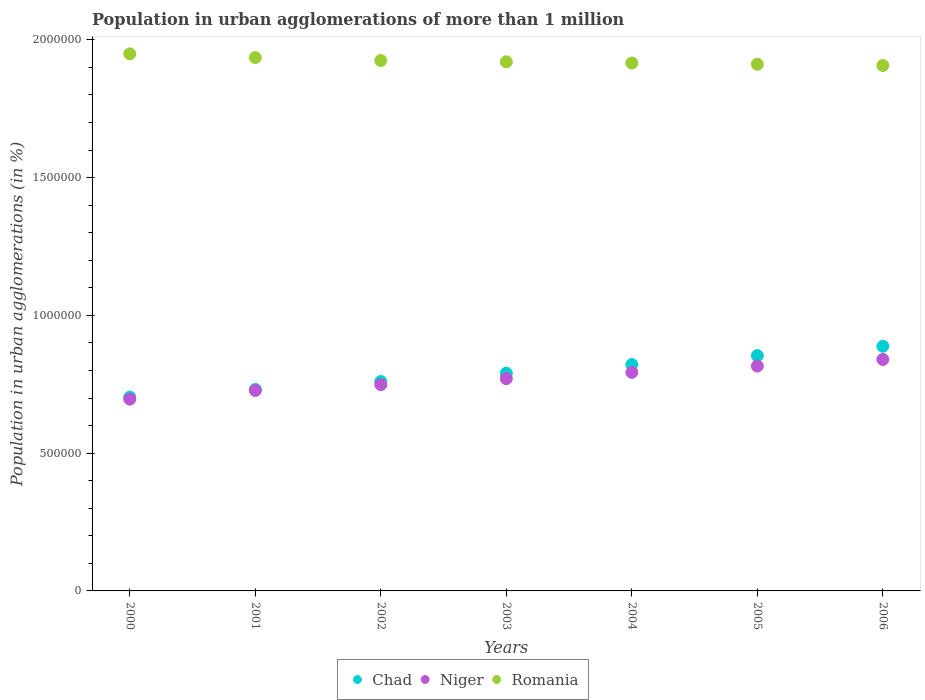How many different coloured dotlines are there?
Provide a succinct answer. 3. What is the population in urban agglomerations in Romania in 2000?
Provide a succinct answer. 1.95e+06. Across all years, what is the maximum population in urban agglomerations in Romania?
Your answer should be compact. 1.95e+06. Across all years, what is the minimum population in urban agglomerations in Chad?
Ensure brevity in your answer.  7.03e+05. In which year was the population in urban agglomerations in Niger maximum?
Offer a very short reply. 2006. What is the total population in urban agglomerations in Romania in the graph?
Provide a succinct answer. 1.35e+07. What is the difference between the population in urban agglomerations in Romania in 2001 and that in 2004?
Your answer should be compact. 1.99e+04. What is the difference between the population in urban agglomerations in Niger in 2006 and the population in urban agglomerations in Chad in 2000?
Keep it short and to the point. 1.37e+05. What is the average population in urban agglomerations in Romania per year?
Ensure brevity in your answer.  1.92e+06. In the year 2001, what is the difference between the population in urban agglomerations in Romania and population in urban agglomerations in Chad?
Your response must be concise. 1.20e+06. What is the ratio of the population in urban agglomerations in Chad in 2000 to that in 2002?
Make the answer very short. 0.93. What is the difference between the highest and the second highest population in urban agglomerations in Niger?
Your response must be concise. 2.38e+04. What is the difference between the highest and the lowest population in urban agglomerations in Niger?
Your answer should be compact. 1.44e+05. In how many years, is the population in urban agglomerations in Niger greater than the average population in urban agglomerations in Niger taken over all years?
Provide a succinct answer. 4. Is the sum of the population in urban agglomerations in Chad in 2000 and 2002 greater than the maximum population in urban agglomerations in Niger across all years?
Your answer should be very brief. Yes. Does the population in urban agglomerations in Niger monotonically increase over the years?
Your answer should be very brief. Yes. Is the population in urban agglomerations in Chad strictly greater than the population in urban agglomerations in Niger over the years?
Your answer should be very brief. Yes. How many dotlines are there?
Your answer should be very brief. 3. Are the values on the major ticks of Y-axis written in scientific E-notation?
Make the answer very short. No. Does the graph contain any zero values?
Your answer should be compact. No. How many legend labels are there?
Ensure brevity in your answer.  3. How are the legend labels stacked?
Keep it short and to the point. Horizontal. What is the title of the graph?
Provide a succinct answer. Population in urban agglomerations of more than 1 million. What is the label or title of the X-axis?
Give a very brief answer. Years. What is the label or title of the Y-axis?
Ensure brevity in your answer.  Population in urban agglomerations (in %). What is the Population in urban agglomerations (in %) in Chad in 2000?
Your response must be concise. 7.03e+05. What is the Population in urban agglomerations (in %) in Niger in 2000?
Give a very brief answer. 6.96e+05. What is the Population in urban agglomerations (in %) in Romania in 2000?
Your answer should be compact. 1.95e+06. What is the Population in urban agglomerations (in %) of Chad in 2001?
Your answer should be compact. 7.31e+05. What is the Population in urban agglomerations (in %) of Niger in 2001?
Provide a short and direct response. 7.27e+05. What is the Population in urban agglomerations (in %) of Romania in 2001?
Provide a succinct answer. 1.94e+06. What is the Population in urban agglomerations (in %) in Chad in 2002?
Provide a succinct answer. 7.60e+05. What is the Population in urban agglomerations (in %) in Niger in 2002?
Provide a short and direct response. 7.49e+05. What is the Population in urban agglomerations (in %) of Romania in 2002?
Your answer should be very brief. 1.93e+06. What is the Population in urban agglomerations (in %) of Chad in 2003?
Offer a terse response. 7.90e+05. What is the Population in urban agglomerations (in %) of Niger in 2003?
Provide a short and direct response. 7.71e+05. What is the Population in urban agglomerations (in %) in Romania in 2003?
Keep it short and to the point. 1.92e+06. What is the Population in urban agglomerations (in %) of Chad in 2004?
Provide a succinct answer. 8.22e+05. What is the Population in urban agglomerations (in %) in Niger in 2004?
Your response must be concise. 7.93e+05. What is the Population in urban agglomerations (in %) in Romania in 2004?
Provide a short and direct response. 1.92e+06. What is the Population in urban agglomerations (in %) of Chad in 2005?
Your answer should be very brief. 8.54e+05. What is the Population in urban agglomerations (in %) in Niger in 2005?
Your response must be concise. 8.16e+05. What is the Population in urban agglomerations (in %) in Romania in 2005?
Offer a very short reply. 1.91e+06. What is the Population in urban agglomerations (in %) of Chad in 2006?
Provide a short and direct response. 8.88e+05. What is the Population in urban agglomerations (in %) in Niger in 2006?
Provide a short and direct response. 8.40e+05. What is the Population in urban agglomerations (in %) in Romania in 2006?
Ensure brevity in your answer.  1.91e+06. Across all years, what is the maximum Population in urban agglomerations (in %) in Chad?
Give a very brief answer. 8.88e+05. Across all years, what is the maximum Population in urban agglomerations (in %) of Niger?
Your answer should be compact. 8.40e+05. Across all years, what is the maximum Population in urban agglomerations (in %) of Romania?
Ensure brevity in your answer.  1.95e+06. Across all years, what is the minimum Population in urban agglomerations (in %) of Chad?
Offer a terse response. 7.03e+05. Across all years, what is the minimum Population in urban agglomerations (in %) in Niger?
Provide a short and direct response. 6.96e+05. Across all years, what is the minimum Population in urban agglomerations (in %) in Romania?
Offer a terse response. 1.91e+06. What is the total Population in urban agglomerations (in %) in Chad in the graph?
Your answer should be compact. 5.55e+06. What is the total Population in urban agglomerations (in %) of Niger in the graph?
Give a very brief answer. 5.39e+06. What is the total Population in urban agglomerations (in %) in Romania in the graph?
Your answer should be compact. 1.35e+07. What is the difference between the Population in urban agglomerations (in %) of Chad in 2000 and that in 2001?
Provide a short and direct response. -2.78e+04. What is the difference between the Population in urban agglomerations (in %) of Niger in 2000 and that in 2001?
Provide a succinct answer. -3.14e+04. What is the difference between the Population in urban agglomerations (in %) in Romania in 2000 and that in 2001?
Offer a very short reply. 1.35e+04. What is the difference between the Population in urban agglomerations (in %) in Chad in 2000 and that in 2002?
Your answer should be very brief. -5.68e+04. What is the difference between the Population in urban agglomerations (in %) in Niger in 2000 and that in 2002?
Keep it short and to the point. -5.27e+04. What is the difference between the Population in urban agglomerations (in %) in Romania in 2000 and that in 2002?
Make the answer very short. 2.43e+04. What is the difference between the Population in urban agglomerations (in %) of Chad in 2000 and that in 2003?
Provide a succinct answer. -8.70e+04. What is the difference between the Population in urban agglomerations (in %) in Niger in 2000 and that in 2003?
Offer a terse response. -7.45e+04. What is the difference between the Population in urban agglomerations (in %) of Romania in 2000 and that in 2003?
Your response must be concise. 2.88e+04. What is the difference between the Population in urban agglomerations (in %) of Chad in 2000 and that in 2004?
Your answer should be compact. -1.18e+05. What is the difference between the Population in urban agglomerations (in %) in Niger in 2000 and that in 2004?
Keep it short and to the point. -9.71e+04. What is the difference between the Population in urban agglomerations (in %) of Romania in 2000 and that in 2004?
Give a very brief answer. 3.33e+04. What is the difference between the Population in urban agglomerations (in %) of Chad in 2000 and that in 2005?
Make the answer very short. -1.51e+05. What is the difference between the Population in urban agglomerations (in %) in Niger in 2000 and that in 2005?
Your response must be concise. -1.20e+05. What is the difference between the Population in urban agglomerations (in %) of Romania in 2000 and that in 2005?
Offer a terse response. 3.78e+04. What is the difference between the Population in urban agglomerations (in %) of Chad in 2000 and that in 2006?
Provide a short and direct response. -1.85e+05. What is the difference between the Population in urban agglomerations (in %) of Niger in 2000 and that in 2006?
Your answer should be very brief. -1.44e+05. What is the difference between the Population in urban agglomerations (in %) in Romania in 2000 and that in 2006?
Ensure brevity in your answer.  4.23e+04. What is the difference between the Population in urban agglomerations (in %) in Chad in 2001 and that in 2002?
Your answer should be very brief. -2.90e+04. What is the difference between the Population in urban agglomerations (in %) of Niger in 2001 and that in 2002?
Offer a terse response. -2.12e+04. What is the difference between the Population in urban agglomerations (in %) in Romania in 2001 and that in 2002?
Provide a short and direct response. 1.08e+04. What is the difference between the Population in urban agglomerations (in %) of Chad in 2001 and that in 2003?
Make the answer very short. -5.91e+04. What is the difference between the Population in urban agglomerations (in %) of Niger in 2001 and that in 2003?
Keep it short and to the point. -4.31e+04. What is the difference between the Population in urban agglomerations (in %) in Romania in 2001 and that in 2003?
Ensure brevity in your answer.  1.54e+04. What is the difference between the Population in urban agglomerations (in %) in Chad in 2001 and that in 2004?
Your answer should be compact. -9.05e+04. What is the difference between the Population in urban agglomerations (in %) in Niger in 2001 and that in 2004?
Offer a very short reply. -6.56e+04. What is the difference between the Population in urban agglomerations (in %) of Romania in 2001 and that in 2004?
Your answer should be very brief. 1.99e+04. What is the difference between the Population in urban agglomerations (in %) in Chad in 2001 and that in 2005?
Your answer should be compact. -1.23e+05. What is the difference between the Population in urban agglomerations (in %) of Niger in 2001 and that in 2005?
Make the answer very short. -8.88e+04. What is the difference between the Population in urban agglomerations (in %) of Romania in 2001 and that in 2005?
Your answer should be very brief. 2.44e+04. What is the difference between the Population in urban agglomerations (in %) of Chad in 2001 and that in 2006?
Offer a very short reply. -1.57e+05. What is the difference between the Population in urban agglomerations (in %) of Niger in 2001 and that in 2006?
Ensure brevity in your answer.  -1.13e+05. What is the difference between the Population in urban agglomerations (in %) in Romania in 2001 and that in 2006?
Make the answer very short. 2.88e+04. What is the difference between the Population in urban agglomerations (in %) of Chad in 2002 and that in 2003?
Your response must be concise. -3.01e+04. What is the difference between the Population in urban agglomerations (in %) in Niger in 2002 and that in 2003?
Your answer should be very brief. -2.19e+04. What is the difference between the Population in urban agglomerations (in %) in Romania in 2002 and that in 2003?
Provide a short and direct response. 4516. What is the difference between the Population in urban agglomerations (in %) in Chad in 2002 and that in 2004?
Offer a terse response. -6.15e+04. What is the difference between the Population in urban agglomerations (in %) of Niger in 2002 and that in 2004?
Offer a very short reply. -4.44e+04. What is the difference between the Population in urban agglomerations (in %) of Romania in 2002 and that in 2004?
Offer a very short reply. 9027. What is the difference between the Population in urban agglomerations (in %) in Chad in 2002 and that in 2005?
Offer a very short reply. -9.40e+04. What is the difference between the Population in urban agglomerations (in %) in Niger in 2002 and that in 2005?
Provide a succinct answer. -6.75e+04. What is the difference between the Population in urban agglomerations (in %) in Romania in 2002 and that in 2005?
Offer a terse response. 1.35e+04. What is the difference between the Population in urban agglomerations (in %) of Chad in 2002 and that in 2006?
Your response must be concise. -1.28e+05. What is the difference between the Population in urban agglomerations (in %) of Niger in 2002 and that in 2006?
Your answer should be very brief. -9.14e+04. What is the difference between the Population in urban agglomerations (in %) in Romania in 2002 and that in 2006?
Offer a very short reply. 1.80e+04. What is the difference between the Population in urban agglomerations (in %) in Chad in 2003 and that in 2004?
Your answer should be compact. -3.14e+04. What is the difference between the Population in urban agglomerations (in %) in Niger in 2003 and that in 2004?
Your answer should be compact. -2.25e+04. What is the difference between the Population in urban agglomerations (in %) in Romania in 2003 and that in 2004?
Keep it short and to the point. 4511. What is the difference between the Population in urban agglomerations (in %) of Chad in 2003 and that in 2005?
Make the answer very short. -6.39e+04. What is the difference between the Population in urban agglomerations (in %) of Niger in 2003 and that in 2005?
Your response must be concise. -4.57e+04. What is the difference between the Population in urban agglomerations (in %) of Romania in 2003 and that in 2005?
Your answer should be very brief. 8999. What is the difference between the Population in urban agglomerations (in %) in Chad in 2003 and that in 2006?
Make the answer very short. -9.78e+04. What is the difference between the Population in urban agglomerations (in %) of Niger in 2003 and that in 2006?
Your answer should be very brief. -6.95e+04. What is the difference between the Population in urban agglomerations (in %) of Romania in 2003 and that in 2006?
Offer a very short reply. 1.35e+04. What is the difference between the Population in urban agglomerations (in %) of Chad in 2004 and that in 2005?
Provide a succinct answer. -3.25e+04. What is the difference between the Population in urban agglomerations (in %) of Niger in 2004 and that in 2005?
Your answer should be compact. -2.31e+04. What is the difference between the Population in urban agglomerations (in %) of Romania in 2004 and that in 2005?
Keep it short and to the point. 4488. What is the difference between the Population in urban agglomerations (in %) of Chad in 2004 and that in 2006?
Offer a terse response. -6.64e+04. What is the difference between the Population in urban agglomerations (in %) of Niger in 2004 and that in 2006?
Your answer should be very brief. -4.70e+04. What is the difference between the Population in urban agglomerations (in %) of Romania in 2004 and that in 2006?
Your answer should be very brief. 8972. What is the difference between the Population in urban agglomerations (in %) in Chad in 2005 and that in 2006?
Make the answer very short. -3.39e+04. What is the difference between the Population in urban agglomerations (in %) in Niger in 2005 and that in 2006?
Offer a very short reply. -2.38e+04. What is the difference between the Population in urban agglomerations (in %) in Romania in 2005 and that in 2006?
Your answer should be very brief. 4484. What is the difference between the Population in urban agglomerations (in %) in Chad in 2000 and the Population in urban agglomerations (in %) in Niger in 2001?
Make the answer very short. -2.41e+04. What is the difference between the Population in urban agglomerations (in %) in Chad in 2000 and the Population in urban agglomerations (in %) in Romania in 2001?
Offer a very short reply. -1.23e+06. What is the difference between the Population in urban agglomerations (in %) of Niger in 2000 and the Population in urban agglomerations (in %) of Romania in 2001?
Ensure brevity in your answer.  -1.24e+06. What is the difference between the Population in urban agglomerations (in %) of Chad in 2000 and the Population in urban agglomerations (in %) of Niger in 2002?
Your answer should be compact. -4.53e+04. What is the difference between the Population in urban agglomerations (in %) in Chad in 2000 and the Population in urban agglomerations (in %) in Romania in 2002?
Offer a very short reply. -1.22e+06. What is the difference between the Population in urban agglomerations (in %) of Niger in 2000 and the Population in urban agglomerations (in %) of Romania in 2002?
Your answer should be compact. -1.23e+06. What is the difference between the Population in urban agglomerations (in %) in Chad in 2000 and the Population in urban agglomerations (in %) in Niger in 2003?
Keep it short and to the point. -6.72e+04. What is the difference between the Population in urban agglomerations (in %) in Chad in 2000 and the Population in urban agglomerations (in %) in Romania in 2003?
Provide a short and direct response. -1.22e+06. What is the difference between the Population in urban agglomerations (in %) in Niger in 2000 and the Population in urban agglomerations (in %) in Romania in 2003?
Your response must be concise. -1.22e+06. What is the difference between the Population in urban agglomerations (in %) in Chad in 2000 and the Population in urban agglomerations (in %) in Niger in 2004?
Keep it short and to the point. -8.97e+04. What is the difference between the Population in urban agglomerations (in %) of Chad in 2000 and the Population in urban agglomerations (in %) of Romania in 2004?
Ensure brevity in your answer.  -1.21e+06. What is the difference between the Population in urban agglomerations (in %) of Niger in 2000 and the Population in urban agglomerations (in %) of Romania in 2004?
Your answer should be compact. -1.22e+06. What is the difference between the Population in urban agglomerations (in %) in Chad in 2000 and the Population in urban agglomerations (in %) in Niger in 2005?
Provide a short and direct response. -1.13e+05. What is the difference between the Population in urban agglomerations (in %) of Chad in 2000 and the Population in urban agglomerations (in %) of Romania in 2005?
Your response must be concise. -1.21e+06. What is the difference between the Population in urban agglomerations (in %) in Niger in 2000 and the Population in urban agglomerations (in %) in Romania in 2005?
Make the answer very short. -1.22e+06. What is the difference between the Population in urban agglomerations (in %) of Chad in 2000 and the Population in urban agglomerations (in %) of Niger in 2006?
Provide a succinct answer. -1.37e+05. What is the difference between the Population in urban agglomerations (in %) of Chad in 2000 and the Population in urban agglomerations (in %) of Romania in 2006?
Your answer should be compact. -1.20e+06. What is the difference between the Population in urban agglomerations (in %) of Niger in 2000 and the Population in urban agglomerations (in %) of Romania in 2006?
Offer a terse response. -1.21e+06. What is the difference between the Population in urban agglomerations (in %) in Chad in 2001 and the Population in urban agglomerations (in %) in Niger in 2002?
Provide a short and direct response. -1.75e+04. What is the difference between the Population in urban agglomerations (in %) of Chad in 2001 and the Population in urban agglomerations (in %) of Romania in 2002?
Provide a short and direct response. -1.19e+06. What is the difference between the Population in urban agglomerations (in %) of Niger in 2001 and the Population in urban agglomerations (in %) of Romania in 2002?
Your response must be concise. -1.20e+06. What is the difference between the Population in urban agglomerations (in %) in Chad in 2001 and the Population in urban agglomerations (in %) in Niger in 2003?
Provide a short and direct response. -3.94e+04. What is the difference between the Population in urban agglomerations (in %) of Chad in 2001 and the Population in urban agglomerations (in %) of Romania in 2003?
Provide a short and direct response. -1.19e+06. What is the difference between the Population in urban agglomerations (in %) in Niger in 2001 and the Population in urban agglomerations (in %) in Romania in 2003?
Your response must be concise. -1.19e+06. What is the difference between the Population in urban agglomerations (in %) in Chad in 2001 and the Population in urban agglomerations (in %) in Niger in 2004?
Provide a short and direct response. -6.19e+04. What is the difference between the Population in urban agglomerations (in %) in Chad in 2001 and the Population in urban agglomerations (in %) in Romania in 2004?
Offer a very short reply. -1.18e+06. What is the difference between the Population in urban agglomerations (in %) of Niger in 2001 and the Population in urban agglomerations (in %) of Romania in 2004?
Make the answer very short. -1.19e+06. What is the difference between the Population in urban agglomerations (in %) in Chad in 2001 and the Population in urban agglomerations (in %) in Niger in 2005?
Your answer should be very brief. -8.50e+04. What is the difference between the Population in urban agglomerations (in %) of Chad in 2001 and the Population in urban agglomerations (in %) of Romania in 2005?
Offer a terse response. -1.18e+06. What is the difference between the Population in urban agglomerations (in %) in Niger in 2001 and the Population in urban agglomerations (in %) in Romania in 2005?
Offer a terse response. -1.18e+06. What is the difference between the Population in urban agglomerations (in %) of Chad in 2001 and the Population in urban agglomerations (in %) of Niger in 2006?
Your answer should be compact. -1.09e+05. What is the difference between the Population in urban agglomerations (in %) of Chad in 2001 and the Population in urban agglomerations (in %) of Romania in 2006?
Give a very brief answer. -1.18e+06. What is the difference between the Population in urban agglomerations (in %) of Niger in 2001 and the Population in urban agglomerations (in %) of Romania in 2006?
Offer a terse response. -1.18e+06. What is the difference between the Population in urban agglomerations (in %) of Chad in 2002 and the Population in urban agglomerations (in %) of Niger in 2003?
Offer a very short reply. -1.04e+04. What is the difference between the Population in urban agglomerations (in %) of Chad in 2002 and the Population in urban agglomerations (in %) of Romania in 2003?
Make the answer very short. -1.16e+06. What is the difference between the Population in urban agglomerations (in %) of Niger in 2002 and the Population in urban agglomerations (in %) of Romania in 2003?
Provide a succinct answer. -1.17e+06. What is the difference between the Population in urban agglomerations (in %) in Chad in 2002 and the Population in urban agglomerations (in %) in Niger in 2004?
Ensure brevity in your answer.  -3.29e+04. What is the difference between the Population in urban agglomerations (in %) of Chad in 2002 and the Population in urban agglomerations (in %) of Romania in 2004?
Offer a terse response. -1.16e+06. What is the difference between the Population in urban agglomerations (in %) in Niger in 2002 and the Population in urban agglomerations (in %) in Romania in 2004?
Ensure brevity in your answer.  -1.17e+06. What is the difference between the Population in urban agglomerations (in %) of Chad in 2002 and the Population in urban agglomerations (in %) of Niger in 2005?
Make the answer very short. -5.60e+04. What is the difference between the Population in urban agglomerations (in %) of Chad in 2002 and the Population in urban agglomerations (in %) of Romania in 2005?
Offer a very short reply. -1.15e+06. What is the difference between the Population in urban agglomerations (in %) in Niger in 2002 and the Population in urban agglomerations (in %) in Romania in 2005?
Give a very brief answer. -1.16e+06. What is the difference between the Population in urban agglomerations (in %) of Chad in 2002 and the Population in urban agglomerations (in %) of Niger in 2006?
Your response must be concise. -7.99e+04. What is the difference between the Population in urban agglomerations (in %) of Chad in 2002 and the Population in urban agglomerations (in %) of Romania in 2006?
Offer a terse response. -1.15e+06. What is the difference between the Population in urban agglomerations (in %) of Niger in 2002 and the Population in urban agglomerations (in %) of Romania in 2006?
Your answer should be very brief. -1.16e+06. What is the difference between the Population in urban agglomerations (in %) in Chad in 2003 and the Population in urban agglomerations (in %) in Niger in 2004?
Offer a terse response. -2770. What is the difference between the Population in urban agglomerations (in %) in Chad in 2003 and the Population in urban agglomerations (in %) in Romania in 2004?
Make the answer very short. -1.13e+06. What is the difference between the Population in urban agglomerations (in %) in Niger in 2003 and the Population in urban agglomerations (in %) in Romania in 2004?
Your answer should be compact. -1.15e+06. What is the difference between the Population in urban agglomerations (in %) in Chad in 2003 and the Population in urban agglomerations (in %) in Niger in 2005?
Make the answer very short. -2.59e+04. What is the difference between the Population in urban agglomerations (in %) of Chad in 2003 and the Population in urban agglomerations (in %) of Romania in 2005?
Offer a very short reply. -1.12e+06. What is the difference between the Population in urban agglomerations (in %) of Niger in 2003 and the Population in urban agglomerations (in %) of Romania in 2005?
Ensure brevity in your answer.  -1.14e+06. What is the difference between the Population in urban agglomerations (in %) of Chad in 2003 and the Population in urban agglomerations (in %) of Niger in 2006?
Give a very brief answer. -4.97e+04. What is the difference between the Population in urban agglomerations (in %) in Chad in 2003 and the Population in urban agglomerations (in %) in Romania in 2006?
Make the answer very short. -1.12e+06. What is the difference between the Population in urban agglomerations (in %) in Niger in 2003 and the Population in urban agglomerations (in %) in Romania in 2006?
Provide a succinct answer. -1.14e+06. What is the difference between the Population in urban agglomerations (in %) of Chad in 2004 and the Population in urban agglomerations (in %) of Niger in 2005?
Your answer should be compact. 5475. What is the difference between the Population in urban agglomerations (in %) in Chad in 2004 and the Population in urban agglomerations (in %) in Romania in 2005?
Make the answer very short. -1.09e+06. What is the difference between the Population in urban agglomerations (in %) in Niger in 2004 and the Population in urban agglomerations (in %) in Romania in 2005?
Offer a very short reply. -1.12e+06. What is the difference between the Population in urban agglomerations (in %) of Chad in 2004 and the Population in urban agglomerations (in %) of Niger in 2006?
Your response must be concise. -1.84e+04. What is the difference between the Population in urban agglomerations (in %) in Chad in 2004 and the Population in urban agglomerations (in %) in Romania in 2006?
Make the answer very short. -1.09e+06. What is the difference between the Population in urban agglomerations (in %) in Niger in 2004 and the Population in urban agglomerations (in %) in Romania in 2006?
Give a very brief answer. -1.11e+06. What is the difference between the Population in urban agglomerations (in %) of Chad in 2005 and the Population in urban agglomerations (in %) of Niger in 2006?
Provide a succinct answer. 1.42e+04. What is the difference between the Population in urban agglomerations (in %) of Chad in 2005 and the Population in urban agglomerations (in %) of Romania in 2006?
Ensure brevity in your answer.  -1.05e+06. What is the difference between the Population in urban agglomerations (in %) in Niger in 2005 and the Population in urban agglomerations (in %) in Romania in 2006?
Offer a very short reply. -1.09e+06. What is the average Population in urban agglomerations (in %) in Chad per year?
Your answer should be very brief. 7.93e+05. What is the average Population in urban agglomerations (in %) of Niger per year?
Your answer should be compact. 7.70e+05. What is the average Population in urban agglomerations (in %) of Romania per year?
Keep it short and to the point. 1.92e+06. In the year 2000, what is the difference between the Population in urban agglomerations (in %) in Chad and Population in urban agglomerations (in %) in Niger?
Your answer should be compact. 7345. In the year 2000, what is the difference between the Population in urban agglomerations (in %) of Chad and Population in urban agglomerations (in %) of Romania?
Give a very brief answer. -1.25e+06. In the year 2000, what is the difference between the Population in urban agglomerations (in %) in Niger and Population in urban agglomerations (in %) in Romania?
Your answer should be very brief. -1.25e+06. In the year 2001, what is the difference between the Population in urban agglomerations (in %) in Chad and Population in urban agglomerations (in %) in Niger?
Make the answer very short. 3753. In the year 2001, what is the difference between the Population in urban agglomerations (in %) in Chad and Population in urban agglomerations (in %) in Romania?
Ensure brevity in your answer.  -1.20e+06. In the year 2001, what is the difference between the Population in urban agglomerations (in %) in Niger and Population in urban agglomerations (in %) in Romania?
Keep it short and to the point. -1.21e+06. In the year 2002, what is the difference between the Population in urban agglomerations (in %) in Chad and Population in urban agglomerations (in %) in Niger?
Give a very brief answer. 1.15e+04. In the year 2002, what is the difference between the Population in urban agglomerations (in %) in Chad and Population in urban agglomerations (in %) in Romania?
Your answer should be compact. -1.16e+06. In the year 2002, what is the difference between the Population in urban agglomerations (in %) of Niger and Population in urban agglomerations (in %) of Romania?
Give a very brief answer. -1.18e+06. In the year 2003, what is the difference between the Population in urban agglomerations (in %) of Chad and Population in urban agglomerations (in %) of Niger?
Give a very brief answer. 1.98e+04. In the year 2003, what is the difference between the Population in urban agglomerations (in %) of Chad and Population in urban agglomerations (in %) of Romania?
Your answer should be compact. -1.13e+06. In the year 2003, what is the difference between the Population in urban agglomerations (in %) in Niger and Population in urban agglomerations (in %) in Romania?
Offer a very short reply. -1.15e+06. In the year 2004, what is the difference between the Population in urban agglomerations (in %) of Chad and Population in urban agglomerations (in %) of Niger?
Offer a very short reply. 2.86e+04. In the year 2004, what is the difference between the Population in urban agglomerations (in %) of Chad and Population in urban agglomerations (in %) of Romania?
Your response must be concise. -1.09e+06. In the year 2004, what is the difference between the Population in urban agglomerations (in %) in Niger and Population in urban agglomerations (in %) in Romania?
Your response must be concise. -1.12e+06. In the year 2005, what is the difference between the Population in urban agglomerations (in %) in Chad and Population in urban agglomerations (in %) in Niger?
Give a very brief answer. 3.80e+04. In the year 2005, what is the difference between the Population in urban agglomerations (in %) in Chad and Population in urban agglomerations (in %) in Romania?
Keep it short and to the point. -1.06e+06. In the year 2005, what is the difference between the Population in urban agglomerations (in %) in Niger and Population in urban agglomerations (in %) in Romania?
Give a very brief answer. -1.10e+06. In the year 2006, what is the difference between the Population in urban agglomerations (in %) in Chad and Population in urban agglomerations (in %) in Niger?
Provide a short and direct response. 4.80e+04. In the year 2006, what is the difference between the Population in urban agglomerations (in %) in Chad and Population in urban agglomerations (in %) in Romania?
Provide a short and direct response. -1.02e+06. In the year 2006, what is the difference between the Population in urban agglomerations (in %) in Niger and Population in urban agglomerations (in %) in Romania?
Your response must be concise. -1.07e+06. What is the ratio of the Population in urban agglomerations (in %) of Chad in 2000 to that in 2001?
Your answer should be compact. 0.96. What is the ratio of the Population in urban agglomerations (in %) of Niger in 2000 to that in 2001?
Your answer should be very brief. 0.96. What is the ratio of the Population in urban agglomerations (in %) of Romania in 2000 to that in 2001?
Offer a very short reply. 1.01. What is the ratio of the Population in urban agglomerations (in %) of Chad in 2000 to that in 2002?
Make the answer very short. 0.93. What is the ratio of the Population in urban agglomerations (in %) of Niger in 2000 to that in 2002?
Ensure brevity in your answer.  0.93. What is the ratio of the Population in urban agglomerations (in %) of Romania in 2000 to that in 2002?
Provide a succinct answer. 1.01. What is the ratio of the Population in urban agglomerations (in %) of Chad in 2000 to that in 2003?
Give a very brief answer. 0.89. What is the ratio of the Population in urban agglomerations (in %) in Niger in 2000 to that in 2003?
Your answer should be very brief. 0.9. What is the ratio of the Population in urban agglomerations (in %) in Romania in 2000 to that in 2003?
Offer a terse response. 1.01. What is the ratio of the Population in urban agglomerations (in %) of Chad in 2000 to that in 2004?
Keep it short and to the point. 0.86. What is the ratio of the Population in urban agglomerations (in %) of Niger in 2000 to that in 2004?
Make the answer very short. 0.88. What is the ratio of the Population in urban agglomerations (in %) of Romania in 2000 to that in 2004?
Your answer should be very brief. 1.02. What is the ratio of the Population in urban agglomerations (in %) of Chad in 2000 to that in 2005?
Your answer should be very brief. 0.82. What is the ratio of the Population in urban agglomerations (in %) in Niger in 2000 to that in 2005?
Offer a terse response. 0.85. What is the ratio of the Population in urban agglomerations (in %) of Romania in 2000 to that in 2005?
Provide a succinct answer. 1.02. What is the ratio of the Population in urban agglomerations (in %) in Chad in 2000 to that in 2006?
Offer a very short reply. 0.79. What is the ratio of the Population in urban agglomerations (in %) in Niger in 2000 to that in 2006?
Give a very brief answer. 0.83. What is the ratio of the Population in urban agglomerations (in %) in Romania in 2000 to that in 2006?
Give a very brief answer. 1.02. What is the ratio of the Population in urban agglomerations (in %) of Chad in 2001 to that in 2002?
Your response must be concise. 0.96. What is the ratio of the Population in urban agglomerations (in %) of Niger in 2001 to that in 2002?
Your response must be concise. 0.97. What is the ratio of the Population in urban agglomerations (in %) in Romania in 2001 to that in 2002?
Keep it short and to the point. 1.01. What is the ratio of the Population in urban agglomerations (in %) in Chad in 2001 to that in 2003?
Ensure brevity in your answer.  0.93. What is the ratio of the Population in urban agglomerations (in %) of Niger in 2001 to that in 2003?
Offer a terse response. 0.94. What is the ratio of the Population in urban agglomerations (in %) of Romania in 2001 to that in 2003?
Keep it short and to the point. 1.01. What is the ratio of the Population in urban agglomerations (in %) of Chad in 2001 to that in 2004?
Offer a terse response. 0.89. What is the ratio of the Population in urban agglomerations (in %) in Niger in 2001 to that in 2004?
Keep it short and to the point. 0.92. What is the ratio of the Population in urban agglomerations (in %) of Romania in 2001 to that in 2004?
Your answer should be compact. 1.01. What is the ratio of the Population in urban agglomerations (in %) in Chad in 2001 to that in 2005?
Your answer should be compact. 0.86. What is the ratio of the Population in urban agglomerations (in %) in Niger in 2001 to that in 2005?
Your response must be concise. 0.89. What is the ratio of the Population in urban agglomerations (in %) of Romania in 2001 to that in 2005?
Keep it short and to the point. 1.01. What is the ratio of the Population in urban agglomerations (in %) of Chad in 2001 to that in 2006?
Keep it short and to the point. 0.82. What is the ratio of the Population in urban agglomerations (in %) in Niger in 2001 to that in 2006?
Ensure brevity in your answer.  0.87. What is the ratio of the Population in urban agglomerations (in %) of Romania in 2001 to that in 2006?
Ensure brevity in your answer.  1.02. What is the ratio of the Population in urban agglomerations (in %) in Chad in 2002 to that in 2003?
Ensure brevity in your answer.  0.96. What is the ratio of the Population in urban agglomerations (in %) of Niger in 2002 to that in 2003?
Your answer should be compact. 0.97. What is the ratio of the Population in urban agglomerations (in %) of Romania in 2002 to that in 2003?
Your answer should be very brief. 1. What is the ratio of the Population in urban agglomerations (in %) in Chad in 2002 to that in 2004?
Ensure brevity in your answer.  0.93. What is the ratio of the Population in urban agglomerations (in %) of Niger in 2002 to that in 2004?
Make the answer very short. 0.94. What is the ratio of the Population in urban agglomerations (in %) in Romania in 2002 to that in 2004?
Provide a short and direct response. 1. What is the ratio of the Population in urban agglomerations (in %) in Chad in 2002 to that in 2005?
Offer a terse response. 0.89. What is the ratio of the Population in urban agglomerations (in %) of Niger in 2002 to that in 2005?
Make the answer very short. 0.92. What is the ratio of the Population in urban agglomerations (in %) in Romania in 2002 to that in 2005?
Offer a terse response. 1.01. What is the ratio of the Population in urban agglomerations (in %) in Chad in 2002 to that in 2006?
Ensure brevity in your answer.  0.86. What is the ratio of the Population in urban agglomerations (in %) in Niger in 2002 to that in 2006?
Give a very brief answer. 0.89. What is the ratio of the Population in urban agglomerations (in %) of Romania in 2002 to that in 2006?
Give a very brief answer. 1.01. What is the ratio of the Population in urban agglomerations (in %) of Chad in 2003 to that in 2004?
Keep it short and to the point. 0.96. What is the ratio of the Population in urban agglomerations (in %) of Niger in 2003 to that in 2004?
Ensure brevity in your answer.  0.97. What is the ratio of the Population in urban agglomerations (in %) of Chad in 2003 to that in 2005?
Your answer should be compact. 0.93. What is the ratio of the Population in urban agglomerations (in %) of Niger in 2003 to that in 2005?
Keep it short and to the point. 0.94. What is the ratio of the Population in urban agglomerations (in %) in Romania in 2003 to that in 2005?
Your answer should be very brief. 1. What is the ratio of the Population in urban agglomerations (in %) in Chad in 2003 to that in 2006?
Provide a succinct answer. 0.89. What is the ratio of the Population in urban agglomerations (in %) in Niger in 2003 to that in 2006?
Offer a terse response. 0.92. What is the ratio of the Population in urban agglomerations (in %) of Romania in 2003 to that in 2006?
Offer a very short reply. 1.01. What is the ratio of the Population in urban agglomerations (in %) in Chad in 2004 to that in 2005?
Make the answer very short. 0.96. What is the ratio of the Population in urban agglomerations (in %) in Niger in 2004 to that in 2005?
Give a very brief answer. 0.97. What is the ratio of the Population in urban agglomerations (in %) of Chad in 2004 to that in 2006?
Your answer should be very brief. 0.93. What is the ratio of the Population in urban agglomerations (in %) of Niger in 2004 to that in 2006?
Give a very brief answer. 0.94. What is the ratio of the Population in urban agglomerations (in %) in Chad in 2005 to that in 2006?
Your answer should be compact. 0.96. What is the ratio of the Population in urban agglomerations (in %) in Niger in 2005 to that in 2006?
Provide a succinct answer. 0.97. What is the ratio of the Population in urban agglomerations (in %) of Romania in 2005 to that in 2006?
Your response must be concise. 1. What is the difference between the highest and the second highest Population in urban agglomerations (in %) of Chad?
Your answer should be very brief. 3.39e+04. What is the difference between the highest and the second highest Population in urban agglomerations (in %) of Niger?
Provide a short and direct response. 2.38e+04. What is the difference between the highest and the second highest Population in urban agglomerations (in %) of Romania?
Provide a short and direct response. 1.35e+04. What is the difference between the highest and the lowest Population in urban agglomerations (in %) of Chad?
Offer a very short reply. 1.85e+05. What is the difference between the highest and the lowest Population in urban agglomerations (in %) in Niger?
Give a very brief answer. 1.44e+05. What is the difference between the highest and the lowest Population in urban agglomerations (in %) of Romania?
Keep it short and to the point. 4.23e+04. 